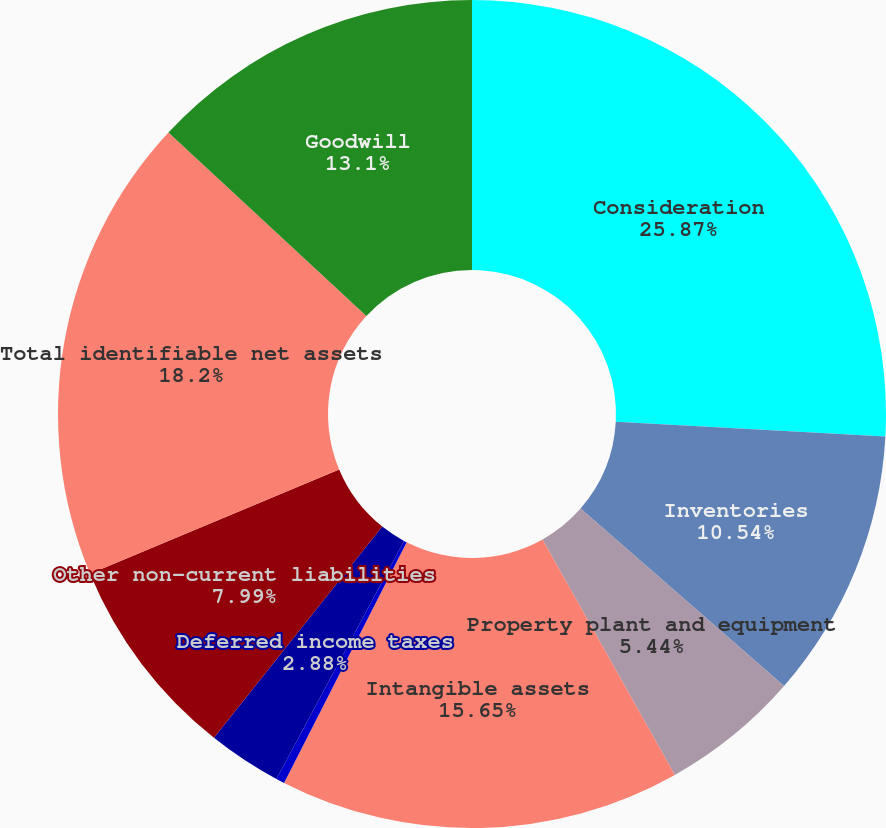<chart> <loc_0><loc_0><loc_500><loc_500><pie_chart><fcel>Consideration<fcel>Inventories<fcel>Property plant and equipment<fcel>Intangible assets<fcel>Accrued expenses and other<fcel>Deferred income taxes<fcel>Other non-current liabilities<fcel>Total identifiable net assets<fcel>Goodwill<nl><fcel>25.87%<fcel>10.54%<fcel>5.44%<fcel>15.65%<fcel>0.33%<fcel>2.88%<fcel>7.99%<fcel>18.2%<fcel>13.1%<nl></chart> 